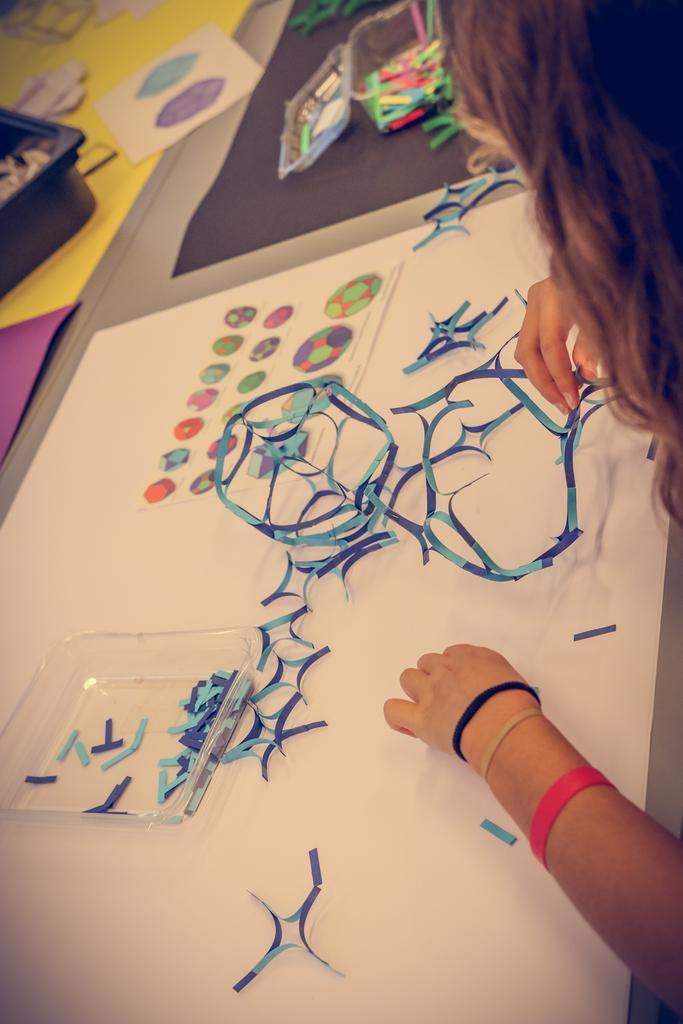Describe this image in one or two sentences. In this image I can see a person hands. I can see few colorful objects on the table. 